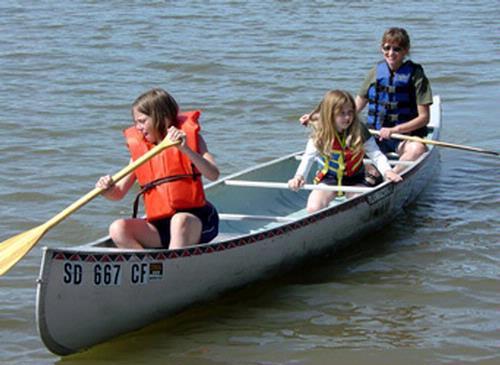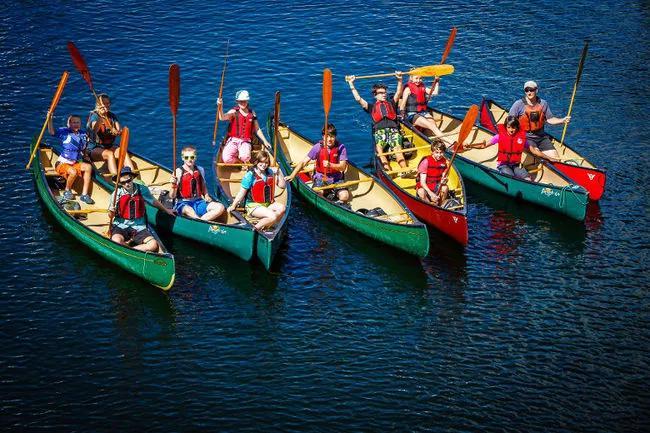The first image is the image on the left, the second image is the image on the right. Assess this claim about the two images: "In at least one image, canoes are docked at the water edge with no people present.". Correct or not? Answer yes or no. No. 